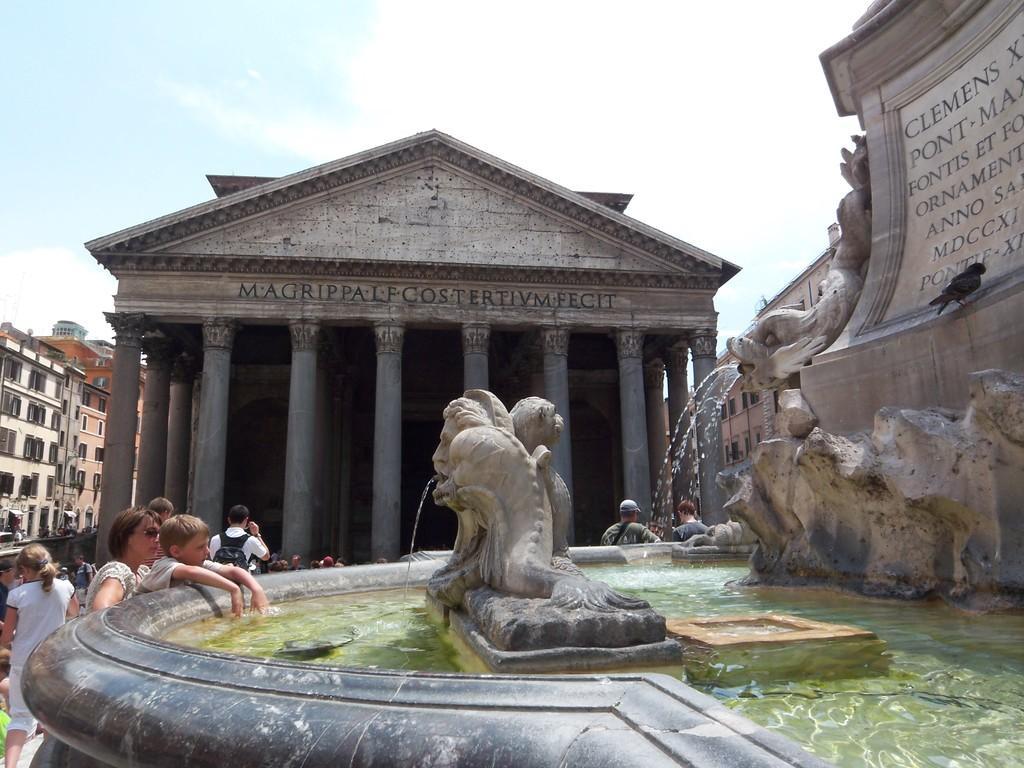Can you describe this image briefly? This image is taken outdoors. At the top of the image there is the sky with clouds. At the bottom of the image there is a fountain with water and there are a few sculptures. On the right side of the image there is a rock with a few sculptures and there is a text on the rock. On the left side of the image there are two buildings with walls, windows, roofs and doors. A few people are standing and a few are walking. In the middle of the image there is a building with walls and there are many pillars. There is a text on the wall. 